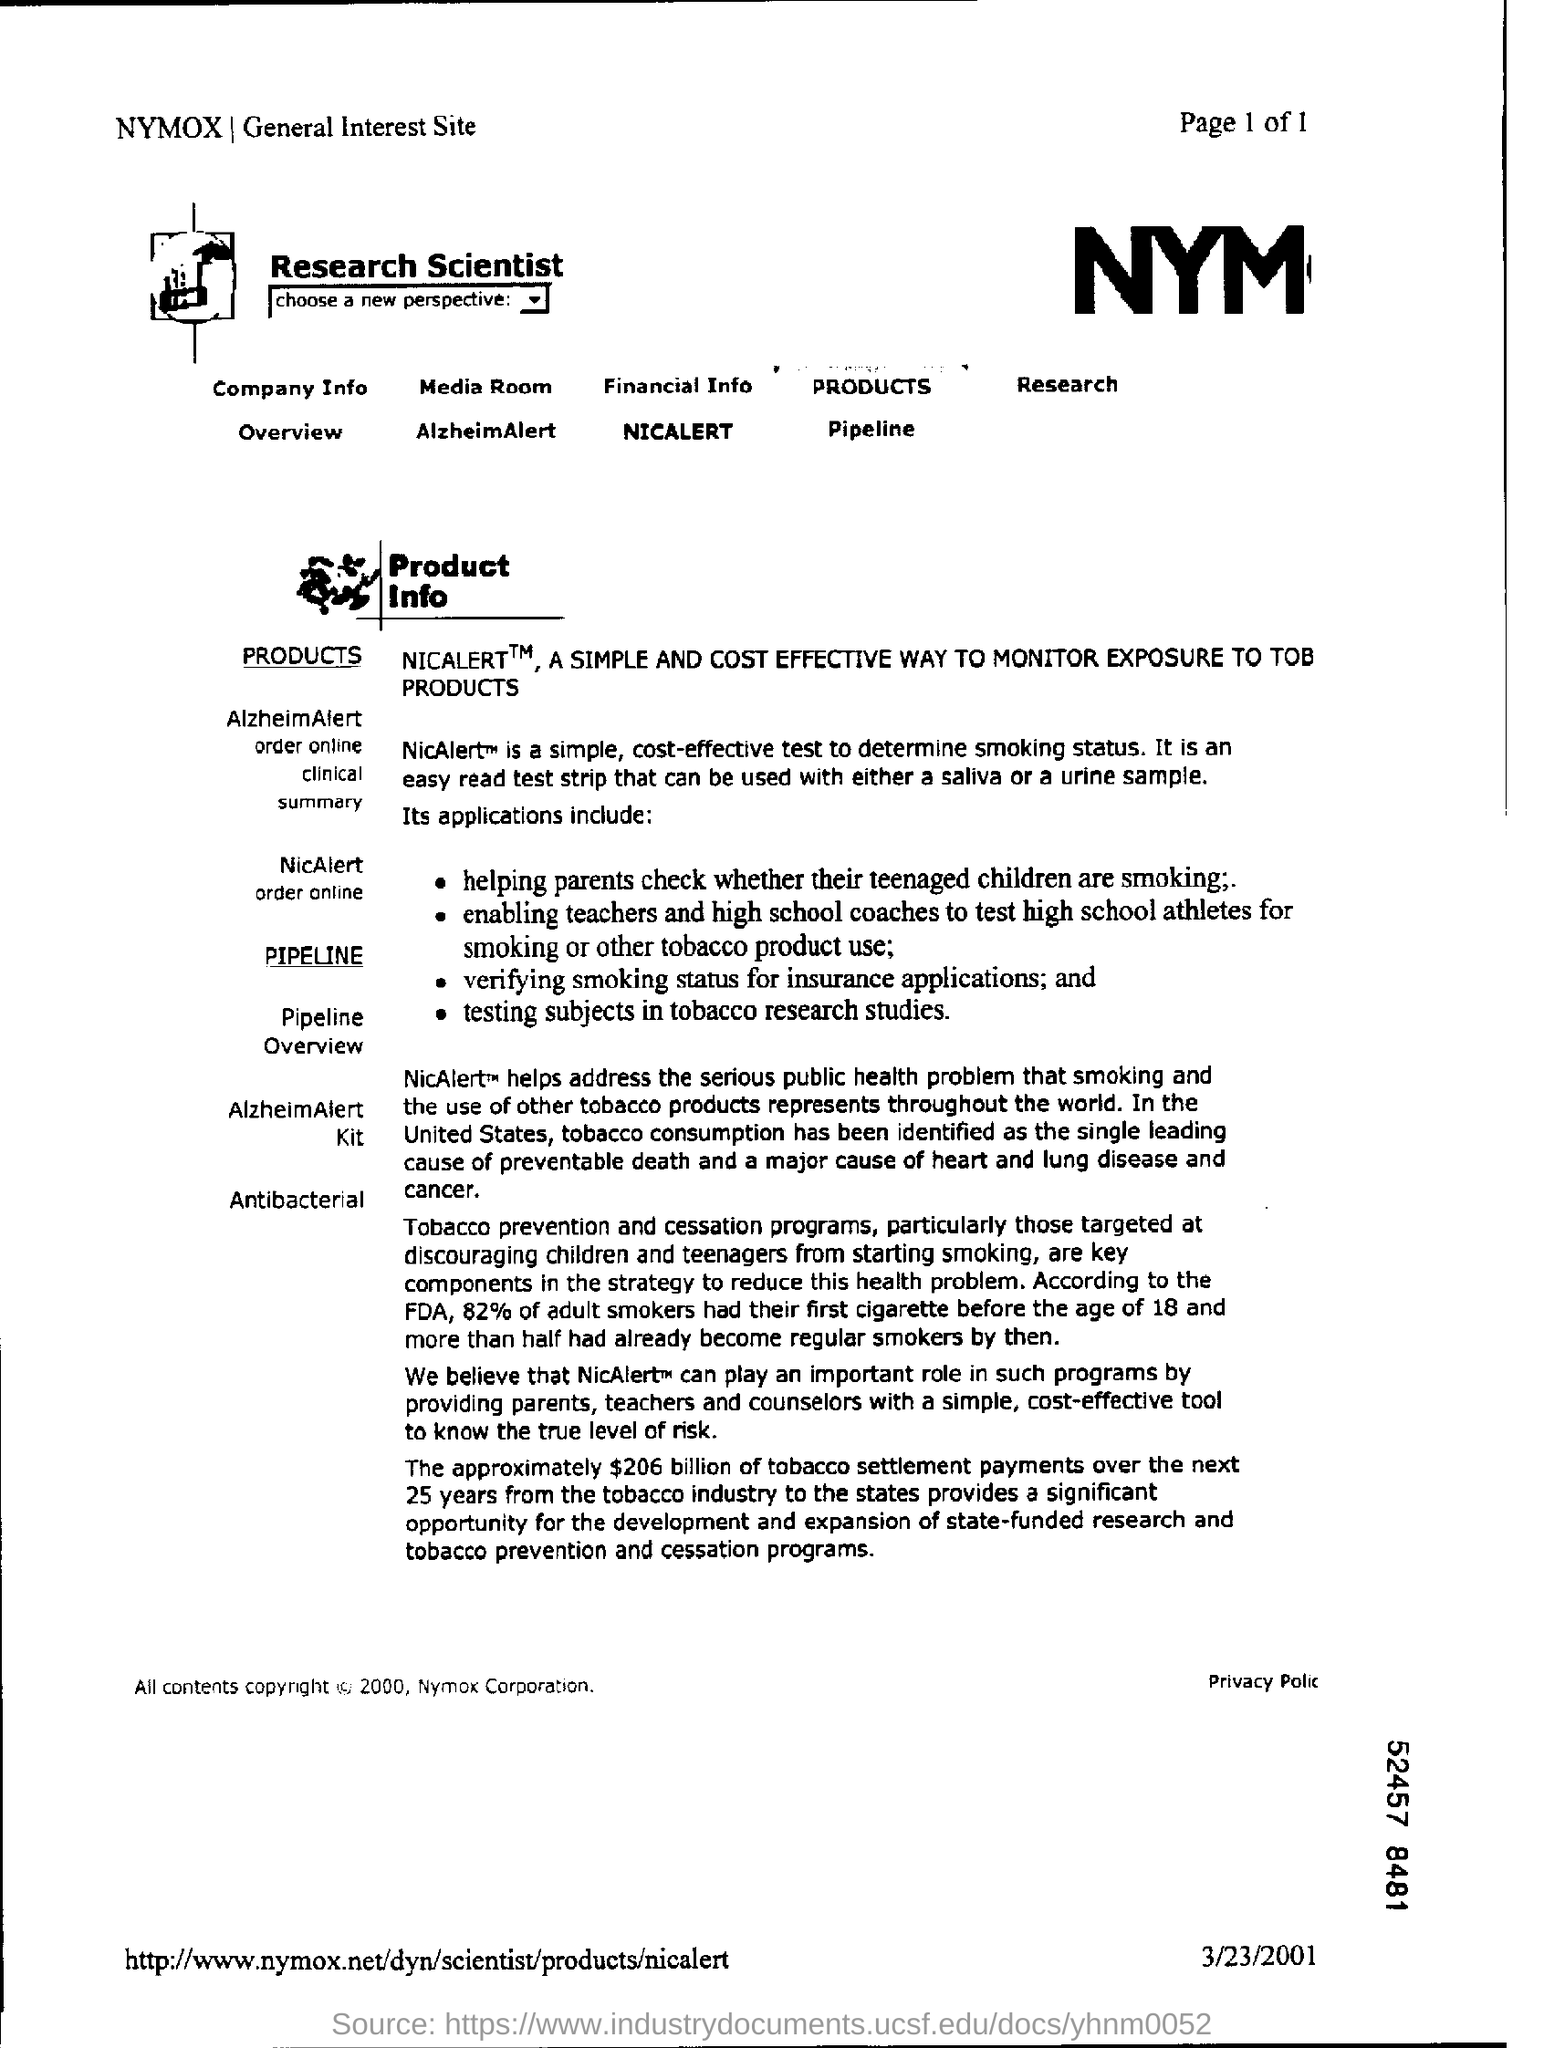What is the name of the General Interest Site given at the left top of the page?
Ensure brevity in your answer.  NYMOX. What is written at the right of logo at the top of page in bold letters?
Your answer should be very brief. Research Scientist. In which country tobacco consumption has been identified as the single leading cause of preventable death?
Ensure brevity in your answer.  United States. According to the FDA, what percentage of adult smokers had their first cigarette before the age of 18?
Offer a very short reply. 82%. According to the which organisation 82% percentage of adult smokers had their first cigarette before the age of 18?
Your answer should be very brief. FDA. Approximately what amount of tobacco settlement payments from the tobacco industry to the states provide a significant opportunity for the development of  state funded research and tobacco prevention programs?
Offer a terse response. $206 billion of tobacco settlement payments over the next 25 years. What is the date given at the bottom right corner of the page?
Your response must be concise. 3/23/2001. According to the FDA, 82% of adult smokers had their first cigarette before which age ?
Your answer should be compact. 18. What is the Page number given at the top right corner of the page?
Make the answer very short. 1 of 1. What is a simple,cost effective test to determine smoking status?
Provide a short and direct response. NicAlert. 